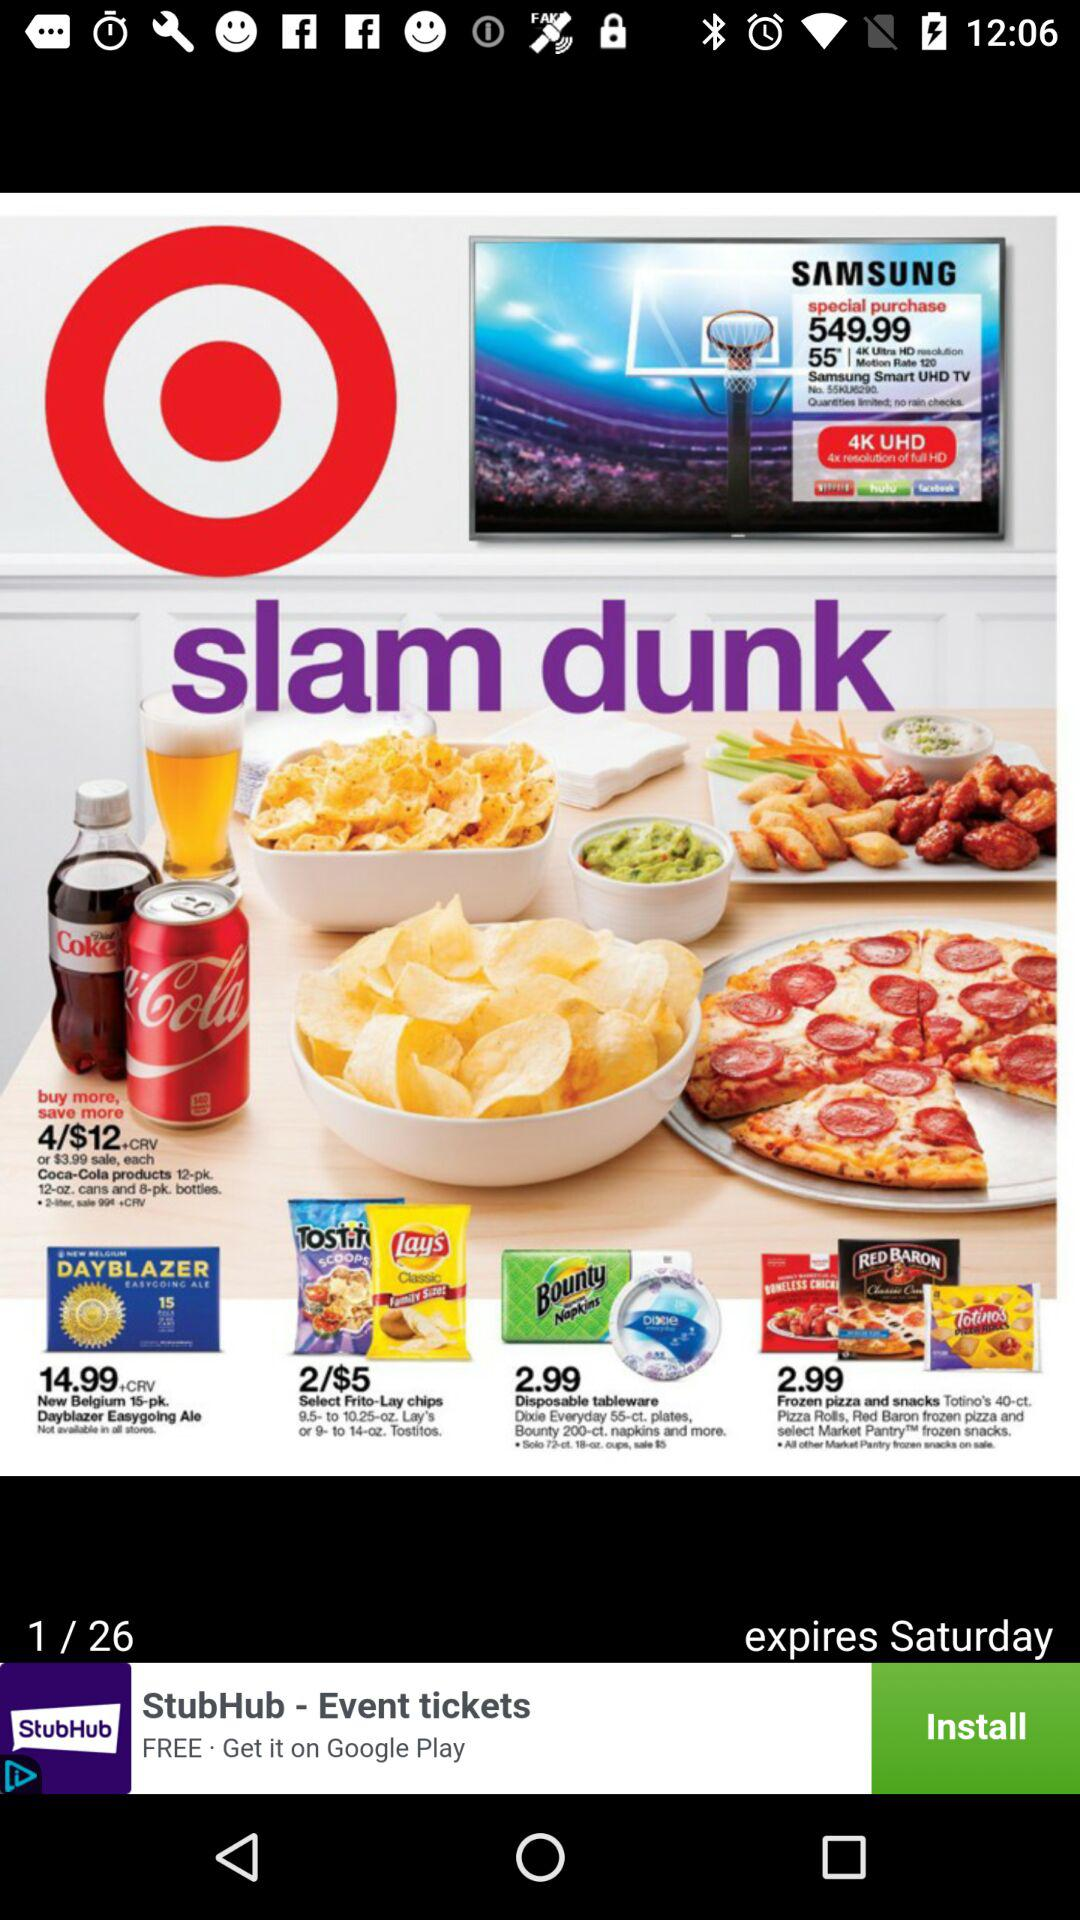On what page are we? You are on page 1. 